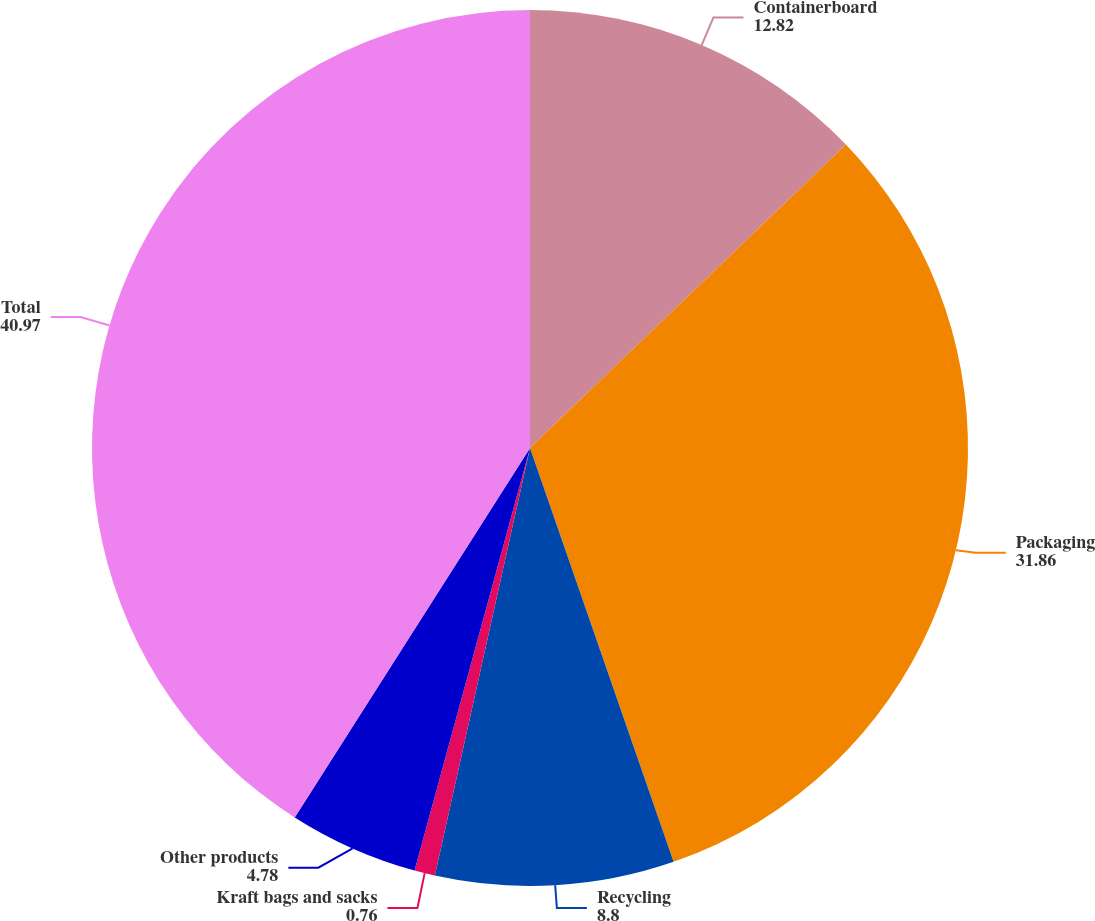<chart> <loc_0><loc_0><loc_500><loc_500><pie_chart><fcel>Containerboard<fcel>Packaging<fcel>Recycling<fcel>Kraft bags and sacks<fcel>Other products<fcel>Total<nl><fcel>12.82%<fcel>31.86%<fcel>8.8%<fcel>0.76%<fcel>4.78%<fcel>40.97%<nl></chart> 